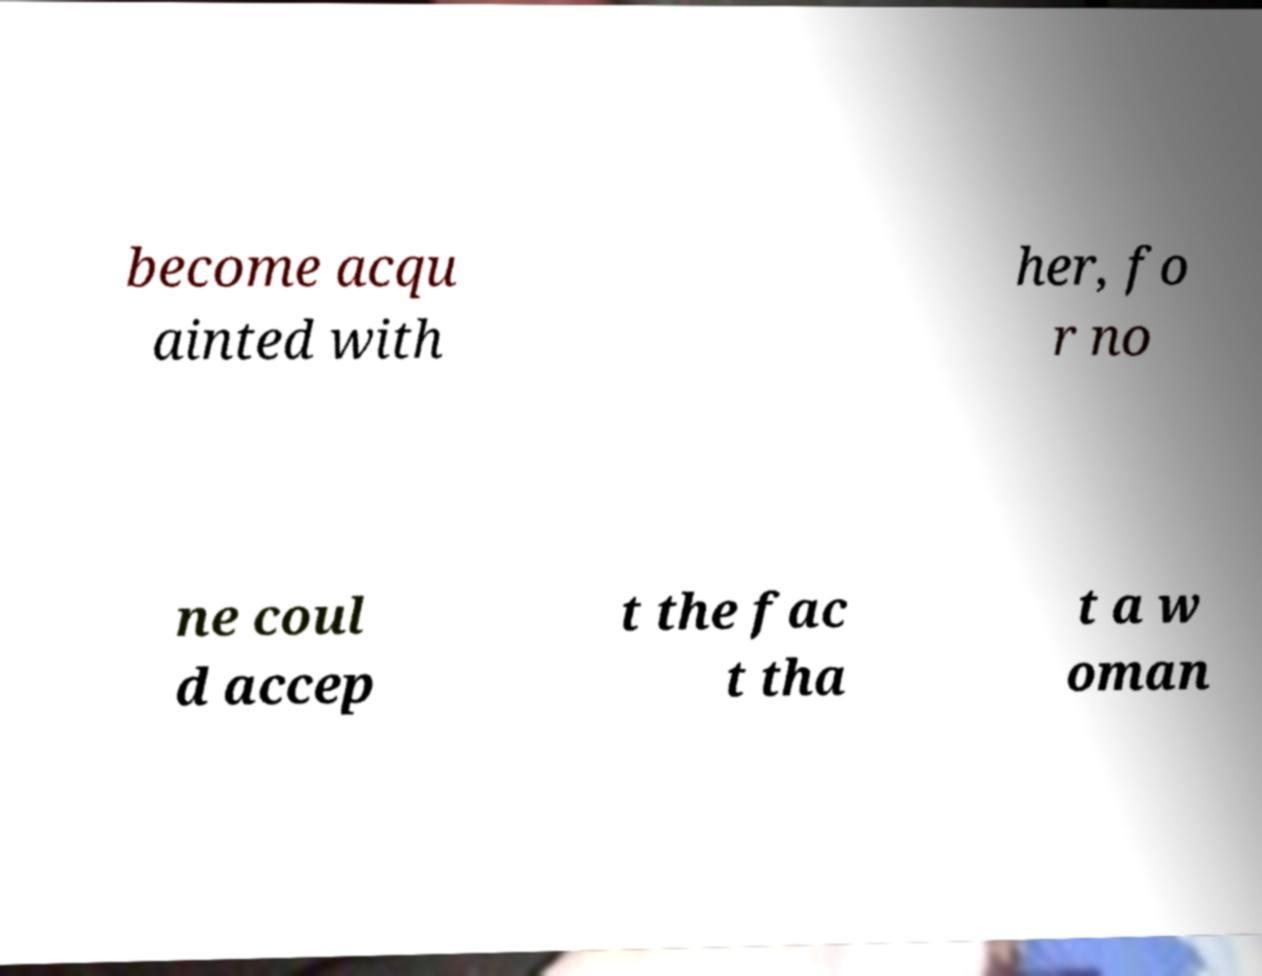Can you read and provide the text displayed in the image?This photo seems to have some interesting text. Can you extract and type it out for me? become acqu ainted with her, fo r no ne coul d accep t the fac t tha t a w oman 